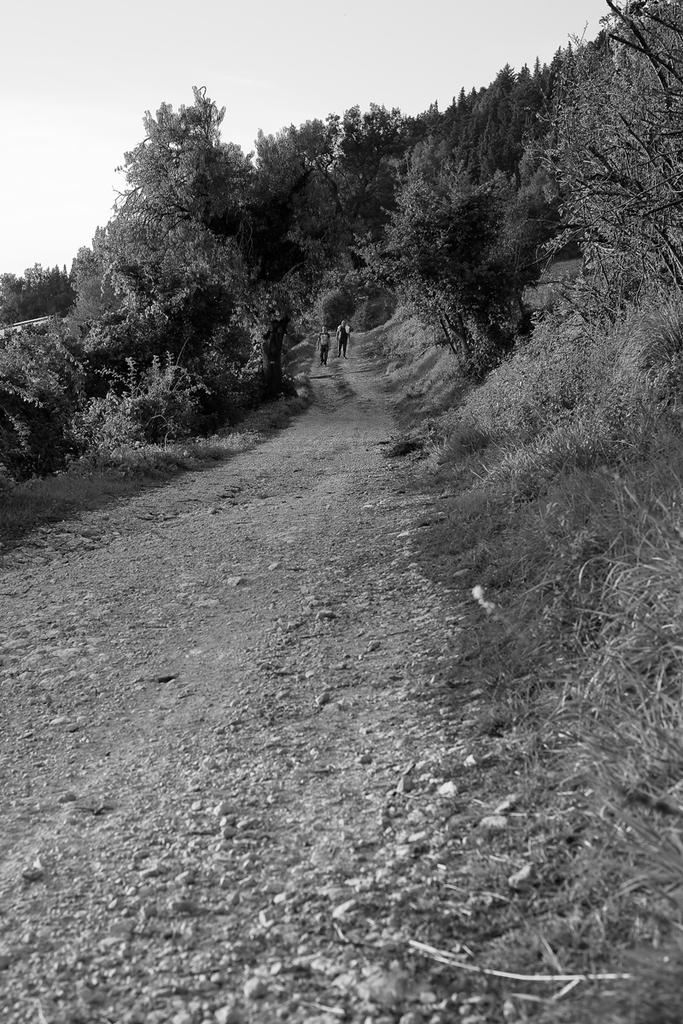What are the two persons in the image doing? The two persons in the image are walking. What type of natural environment can be seen in the image? There are trees visible in the image. What is visible in the background of the image? The sky is visible in the background of the image. What is the color scheme of the image? The image is in black and white. What type of cover is protecting the persons from the sleet in the image? There is no mention of sleet or any type of cover in the image; it is a black and white image of two persons walking. 